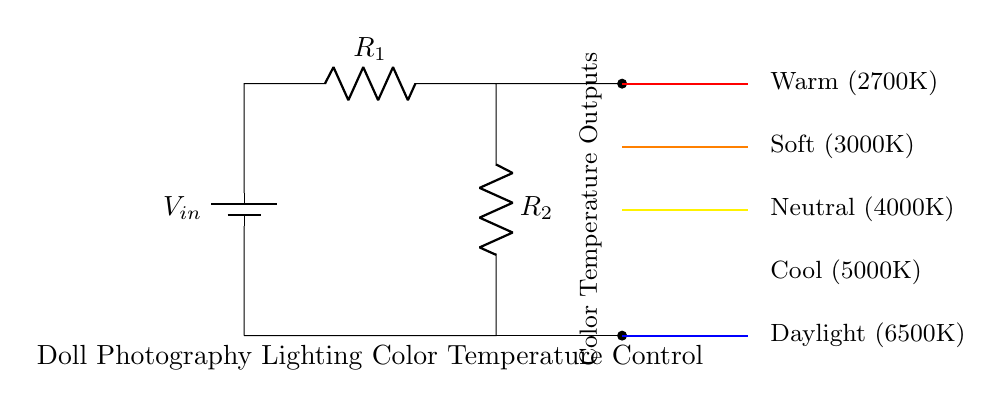What is the input voltage labeled in the circuit? The input voltage is labeled as V_in, which indicates the source voltage supplied to the circuit. It is located near the top of the circuit diagram.
Answer: V_in How many resistors are present in this voltage divider circuit? The circuit diagram shows two resistors labeled R_1 and R_2 connected in series, indicating there are two resistors in total.
Answer: 2 What is the color temperature assigned to the output labeled as "Warm"? The output labeled "Warm" indicates a color temperature of 2700K, which is specified next to the output line in the diagram.
Answer: 2700K Which color temperature output corresponds to the highest temperature? The highest color temperature output is labeled as "Daylight", which corresponds to a value of 6500K located at the bottom of the color temperature outputs in the diagram.
Answer: 6500K What is the organization of the color temperature outputs from top to bottom? The color temperature outputs are organized from warm to cool temperatures, starting from Warm at the top (2700K) down to Daylight at the bottom (6500K) in descending order of temperature.
Answer: Warm to Daylight If R_1 is increased, what effect does it have on the output voltage for each color temperature? Increasing R_1 will decrease the output voltage across R_2, which in turn will affect the different color temperatures generated by this voltage divider, causing them to shift accordingly.
Answer: Decrease output voltage 